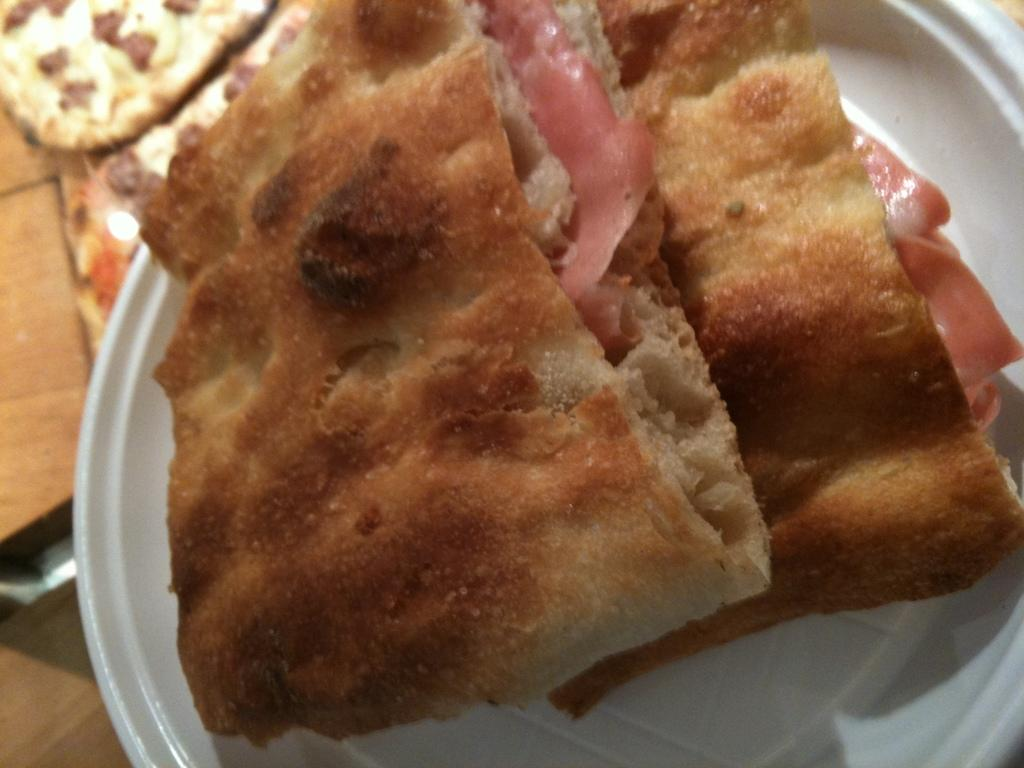What is on the plate that is visible in the image? There is a plate with baked items in the image. What type of food can be seen on the table in the image? There are pizza pieces on the table in the image. What type of bean is present on the plate in the image? There is no bean present on the plate in the image; it contains baked items. What material is the brass used for in the image? There is no brass present in the image. 